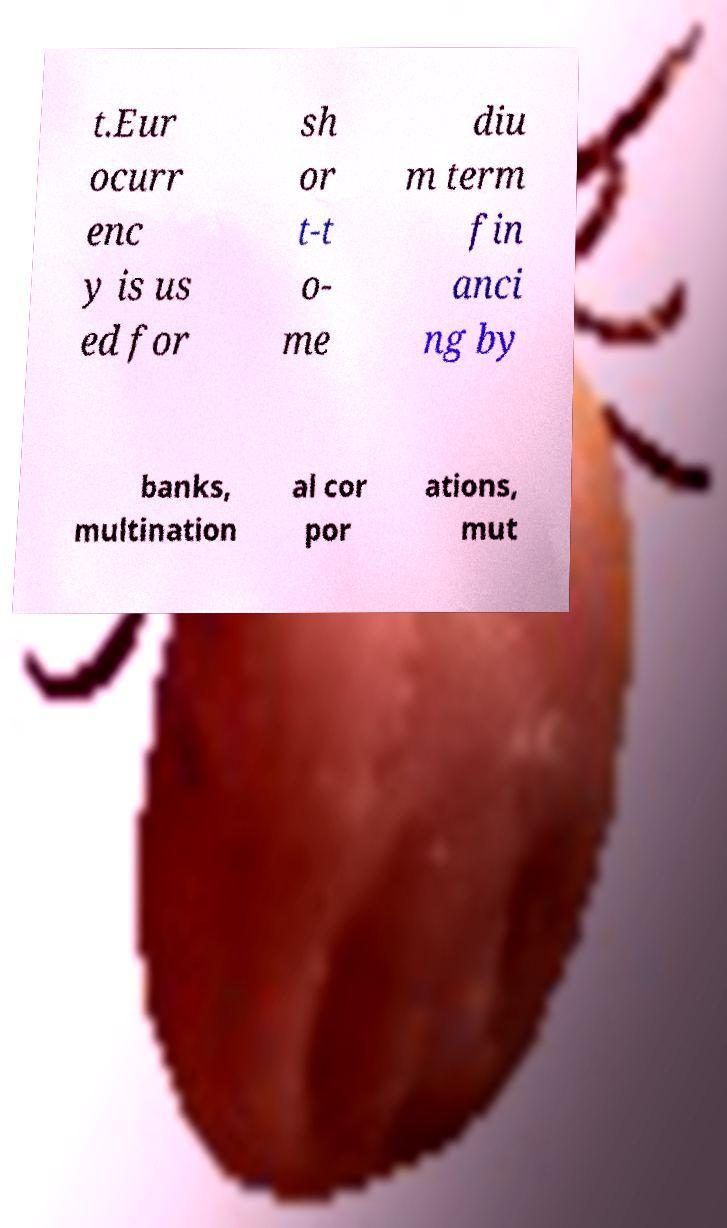Can you accurately transcribe the text from the provided image for me? t.Eur ocurr enc y is us ed for sh or t-t o- me diu m term fin anci ng by banks, multination al cor por ations, mut 